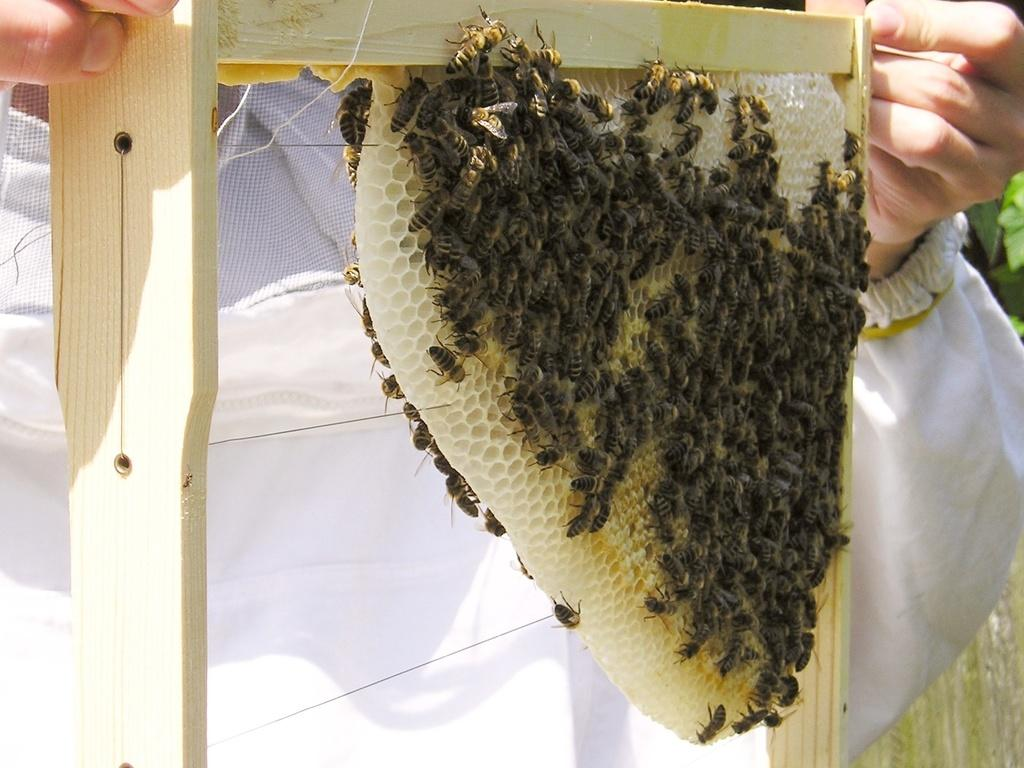What is the person in the image holding? The person is holding a honeycomb in the image. What insects can be seen in the image? Honey bees are visible in the image. What type of vegetation is on the right side of the image? There are leaves on the right side of the image. What type of cake is being served in the image? There is no cake present in the image. 